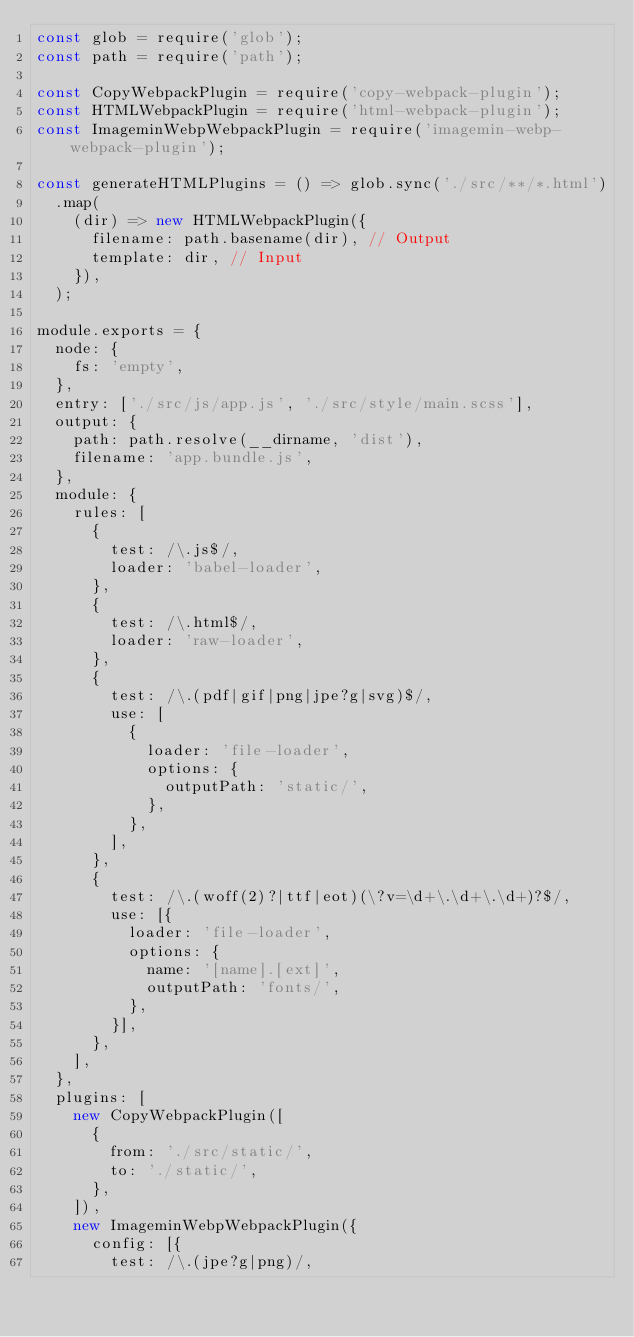Convert code to text. <code><loc_0><loc_0><loc_500><loc_500><_JavaScript_>const glob = require('glob');
const path = require('path');

const CopyWebpackPlugin = require('copy-webpack-plugin');
const HTMLWebpackPlugin = require('html-webpack-plugin');
const ImageminWebpWebpackPlugin = require('imagemin-webp-webpack-plugin');

const generateHTMLPlugins = () => glob.sync('./src/**/*.html')
  .map(
    (dir) => new HTMLWebpackPlugin({
      filename: path.basename(dir), // Output
      template: dir, // Input
    }),
  );

module.exports = {
  node: {
    fs: 'empty',
  },
  entry: ['./src/js/app.js', './src/style/main.scss'],
  output: {
    path: path.resolve(__dirname, 'dist'),
    filename: 'app.bundle.js',
  },
  module: {
    rules: [
      {
        test: /\.js$/,
        loader: 'babel-loader',
      },
      {
        test: /\.html$/,
        loader: 'raw-loader',
      },
      {
        test: /\.(pdf|gif|png|jpe?g|svg)$/,
        use: [
          {
            loader: 'file-loader',
            options: {
              outputPath: 'static/',
            },
          },
        ],
      },
      {
        test: /\.(woff(2)?|ttf|eot)(\?v=\d+\.\d+\.\d+)?$/,
        use: [{
          loader: 'file-loader',
          options: {
            name: '[name].[ext]',
            outputPath: 'fonts/',
          },
        }],
      },
    ],
  },
  plugins: [
    new CopyWebpackPlugin([
      {
        from: './src/static/',
        to: './static/',
      },
    ]),
    new ImageminWebpWebpackPlugin({
      config: [{
        test: /\.(jpe?g|png)/,</code> 